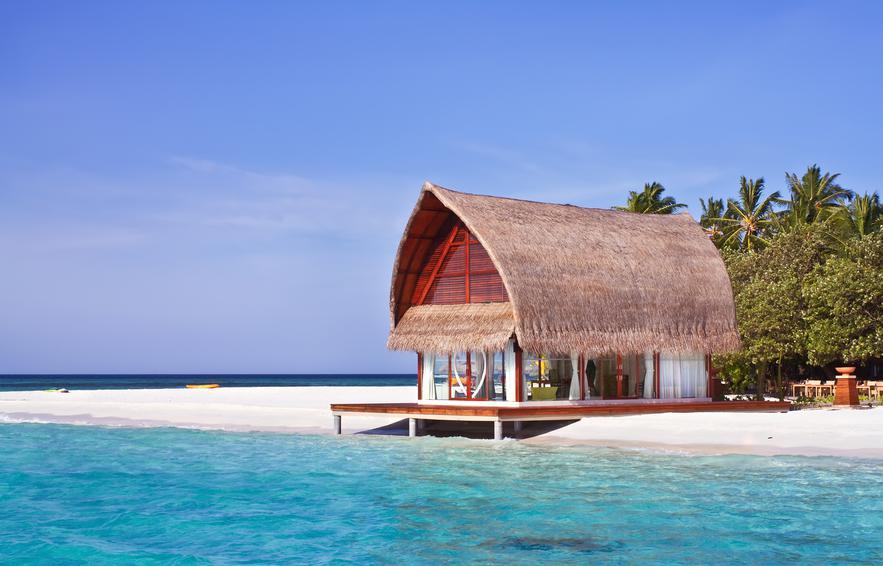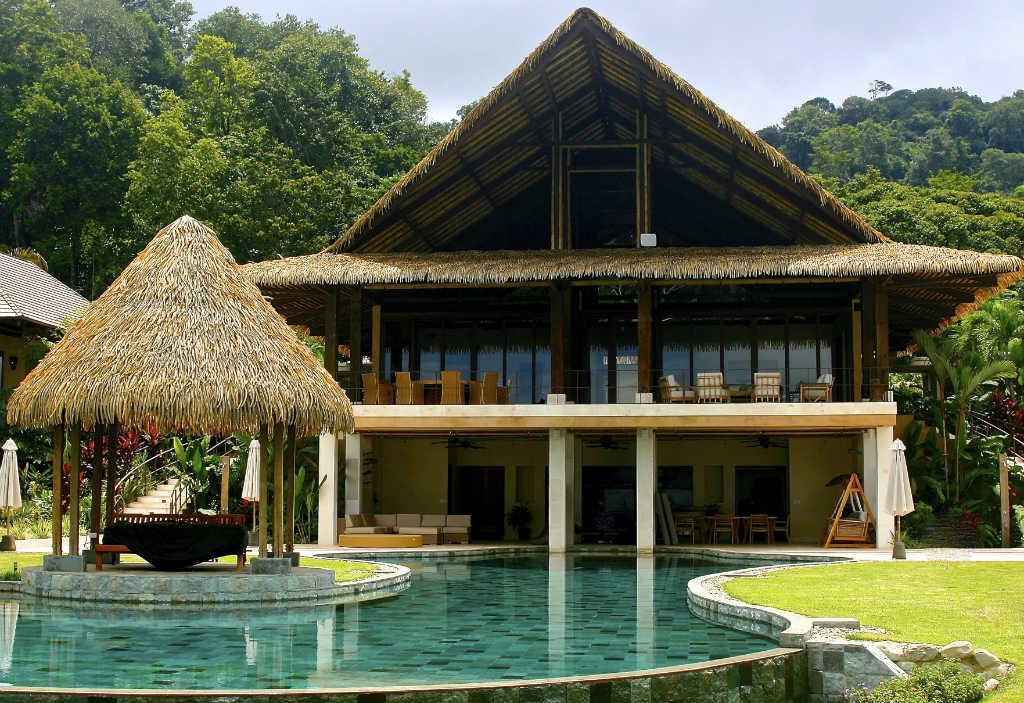The first image is the image on the left, the second image is the image on the right. Given the left and right images, does the statement "Left and right images feature thatch-roofed buildings on a beach, and the right image includes a curving swimming pool." hold true? Answer yes or no. Yes. The first image is the image on the left, the second image is the image on the right. Assess this claim about the two images: "A pier crosses the water in the image on the left.". Correct or not? Answer yes or no. No. 